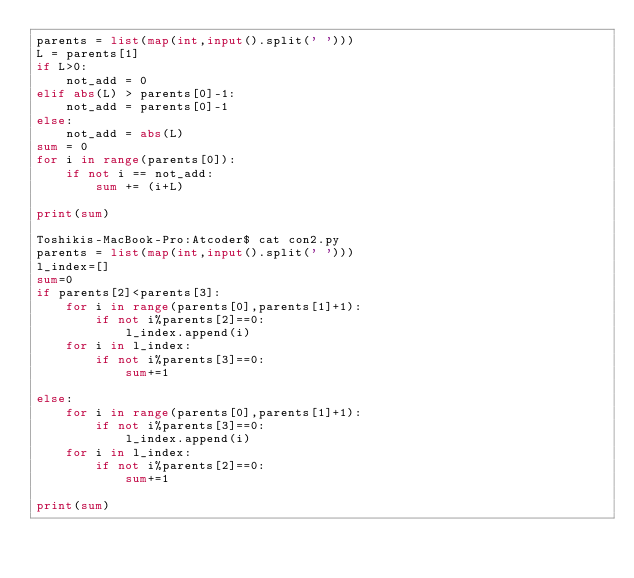Convert code to text. <code><loc_0><loc_0><loc_500><loc_500><_Python_>parents = list(map(int,input().split(' ')))
L = parents[1]
if L>0:
    not_add = 0
elif abs(L) > parents[0]-1:
    not_add = parents[0]-1
else:
    not_add = abs(L)
sum = 0
for i in range(parents[0]):
    if not i == not_add:
        sum += (i+L)

print(sum)

Toshikis-MacBook-Pro:Atcoder$ cat con2.py
parents = list(map(int,input().split(' ')))
l_index=[]
sum=0
if parents[2]<parents[3]:
    for i in range(parents[0],parents[1]+1):
        if not i%parents[2]==0:
            l_index.append(i)
    for i in l_index:
        if not i%parents[3]==0:
            sum+=1

else:
    for i in range(parents[0],parents[1]+1):
        if not i%parents[3]==0:
            l_index.append(i)
    for i in l_index:
        if not i%parents[2]==0:
            sum+=1

print(sum)</code> 